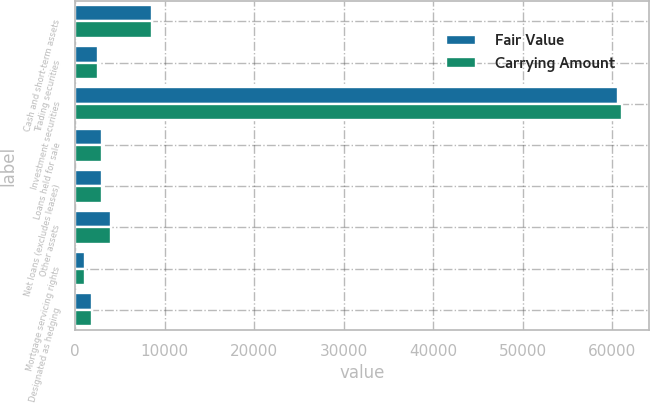Convert chart to OTSL. <chart><loc_0><loc_0><loc_500><loc_500><stacked_bar_chart><ecel><fcel>Cash and short-term assets<fcel>Trading securities<fcel>Investment securities<fcel>Loans held for sale<fcel>Net loans (excludes leases)<fcel>Other assets<fcel>Mortgage servicing rights<fcel>Designated as hedging<nl><fcel>Fair Value<fcel>8567<fcel>2513<fcel>60634<fcel>2936<fcel>2937.5<fcel>4019<fcel>1115<fcel>1888<nl><fcel>Carrying Amount<fcel>8567<fcel>2513<fcel>61018<fcel>2939<fcel>2937.5<fcel>4019<fcel>1118<fcel>1888<nl></chart> 